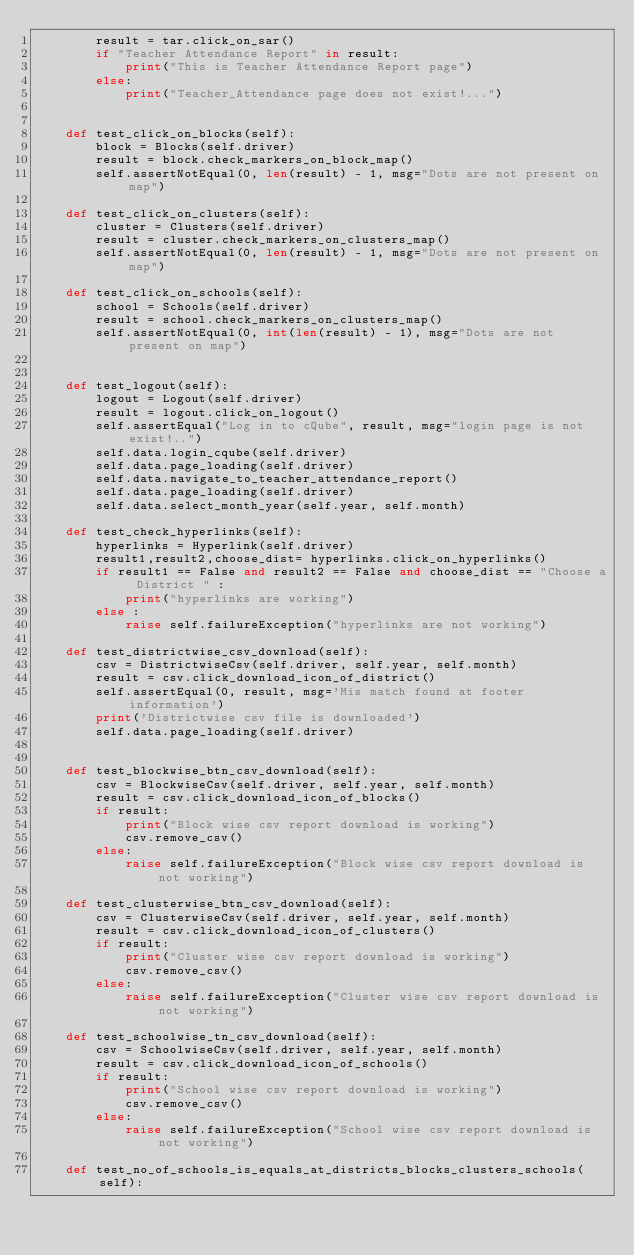Convert code to text. <code><loc_0><loc_0><loc_500><loc_500><_Python_>        result = tar.click_on_sar()
        if "Teacher Attendance Report" in result:
            print("This is Teacher Attendance Report page")
        else:
            print("Teacher_Attendance page does not exist!...")


    def test_click_on_blocks(self):
        block = Blocks(self.driver)
        result = block.check_markers_on_block_map()
        self.assertNotEqual(0, len(result) - 1, msg="Dots are not present on map")

    def test_click_on_clusters(self):
        cluster = Clusters(self.driver)
        result = cluster.check_markers_on_clusters_map()
        self.assertNotEqual(0, len(result) - 1, msg="Dots are not present on map")

    def test_click_on_schools(self):
        school = Schools(self.driver)
        result = school.check_markers_on_clusters_map()
        self.assertNotEqual(0, int(len(result) - 1), msg="Dots are not present on map")


    def test_logout(self):
        logout = Logout(self.driver)
        result = logout.click_on_logout()
        self.assertEqual("Log in to cQube", result, msg="login page is not exist!..")
        self.data.login_cqube(self.driver)
        self.data.page_loading(self.driver)
        self.data.navigate_to_teacher_attendance_report()
        self.data.page_loading(self.driver)
        self.data.select_month_year(self.year, self.month)

    def test_check_hyperlinks(self):
        hyperlinks = Hyperlink(self.driver)
        result1,result2,choose_dist= hyperlinks.click_on_hyperlinks()
        if result1 == False and result2 == False and choose_dist == "Choose a District " :
            print("hyperlinks are working")
        else :
            raise self.failureException("hyperlinks are not working")

    def test_districtwise_csv_download(self):
        csv = DistrictwiseCsv(self.driver, self.year, self.month)
        result = csv.click_download_icon_of_district()
        self.assertEqual(0, result, msg='Mis match found at footer information')
        print('Districtwise csv file is downloaded')
        self.data.page_loading(self.driver)


    def test_blockwise_btn_csv_download(self):
        csv = BlockwiseCsv(self.driver, self.year, self.month)
        result = csv.click_download_icon_of_blocks()
        if result:
            print("Block wise csv report download is working")
            csv.remove_csv()
        else:
            raise self.failureException("Block wise csv report download is not working")

    def test_clusterwise_btn_csv_download(self):
        csv = ClusterwiseCsv(self.driver, self.year, self.month)
        result = csv.click_download_icon_of_clusters()
        if result:
            print("Cluster wise csv report download is working")
            csv.remove_csv()
        else:
            raise self.failureException("Cluster wise csv report download is not working")

    def test_schoolwise_tn_csv_download(self):
        csv = SchoolwiseCsv(self.driver, self.year, self.month)
        result = csv.click_download_icon_of_schools()
        if result:
            print("School wise csv report download is working")
            csv.remove_csv()
        else:
            raise self.failureException("School wise csv report download is not working")

    def test_no_of_schools_is_equals_at_districts_blocks_clusters_schools(self):</code> 